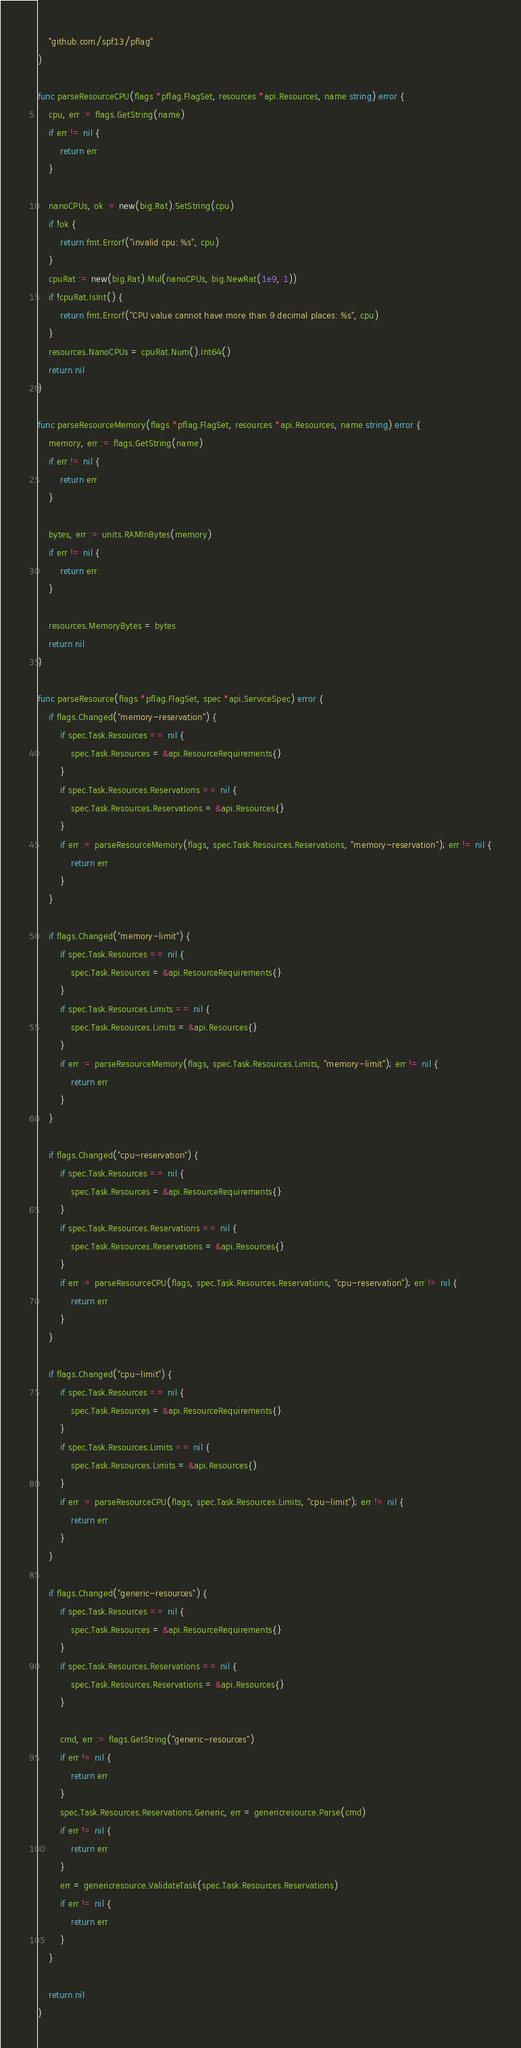<code> <loc_0><loc_0><loc_500><loc_500><_Go_>	"github.com/spf13/pflag"
)

func parseResourceCPU(flags *pflag.FlagSet, resources *api.Resources, name string) error {
	cpu, err := flags.GetString(name)
	if err != nil {
		return err
	}

	nanoCPUs, ok := new(big.Rat).SetString(cpu)
	if !ok {
		return fmt.Errorf("invalid cpu: %s", cpu)
	}
	cpuRat := new(big.Rat).Mul(nanoCPUs, big.NewRat(1e9, 1))
	if !cpuRat.IsInt() {
		return fmt.Errorf("CPU value cannot have more than 9 decimal places: %s", cpu)
	}
	resources.NanoCPUs = cpuRat.Num().Int64()
	return nil
}

func parseResourceMemory(flags *pflag.FlagSet, resources *api.Resources, name string) error {
	memory, err := flags.GetString(name)
	if err != nil {
		return err
	}

	bytes, err := units.RAMInBytes(memory)
	if err != nil {
		return err
	}

	resources.MemoryBytes = bytes
	return nil
}

func parseResource(flags *pflag.FlagSet, spec *api.ServiceSpec) error {
	if flags.Changed("memory-reservation") {
		if spec.Task.Resources == nil {
			spec.Task.Resources = &api.ResourceRequirements{}
		}
		if spec.Task.Resources.Reservations == nil {
			spec.Task.Resources.Reservations = &api.Resources{}
		}
		if err := parseResourceMemory(flags, spec.Task.Resources.Reservations, "memory-reservation"); err != nil {
			return err
		}
	}

	if flags.Changed("memory-limit") {
		if spec.Task.Resources == nil {
			spec.Task.Resources = &api.ResourceRequirements{}
		}
		if spec.Task.Resources.Limits == nil {
			spec.Task.Resources.Limits = &api.Resources{}
		}
		if err := parseResourceMemory(flags, spec.Task.Resources.Limits, "memory-limit"); err != nil {
			return err
		}
	}

	if flags.Changed("cpu-reservation") {
		if spec.Task.Resources == nil {
			spec.Task.Resources = &api.ResourceRequirements{}
		}
		if spec.Task.Resources.Reservations == nil {
			spec.Task.Resources.Reservations = &api.Resources{}
		}
		if err := parseResourceCPU(flags, spec.Task.Resources.Reservations, "cpu-reservation"); err != nil {
			return err
		}
	}

	if flags.Changed("cpu-limit") {
		if spec.Task.Resources == nil {
			spec.Task.Resources = &api.ResourceRequirements{}
		}
		if spec.Task.Resources.Limits == nil {
			spec.Task.Resources.Limits = &api.Resources{}
		}
		if err := parseResourceCPU(flags, spec.Task.Resources.Limits, "cpu-limit"); err != nil {
			return err
		}
	}

	if flags.Changed("generic-resources") {
		if spec.Task.Resources == nil {
			spec.Task.Resources = &api.ResourceRequirements{}
		}
		if spec.Task.Resources.Reservations == nil {
			spec.Task.Resources.Reservations = &api.Resources{}
		}

		cmd, err := flags.GetString("generic-resources")
		if err != nil {
			return err
		}
		spec.Task.Resources.Reservations.Generic, err = genericresource.Parse(cmd)
		if err != nil {
			return err
		}
		err = genericresource.ValidateTask(spec.Task.Resources.Reservations)
		if err != nil {
			return err
		}
	}

	return nil
}
</code> 